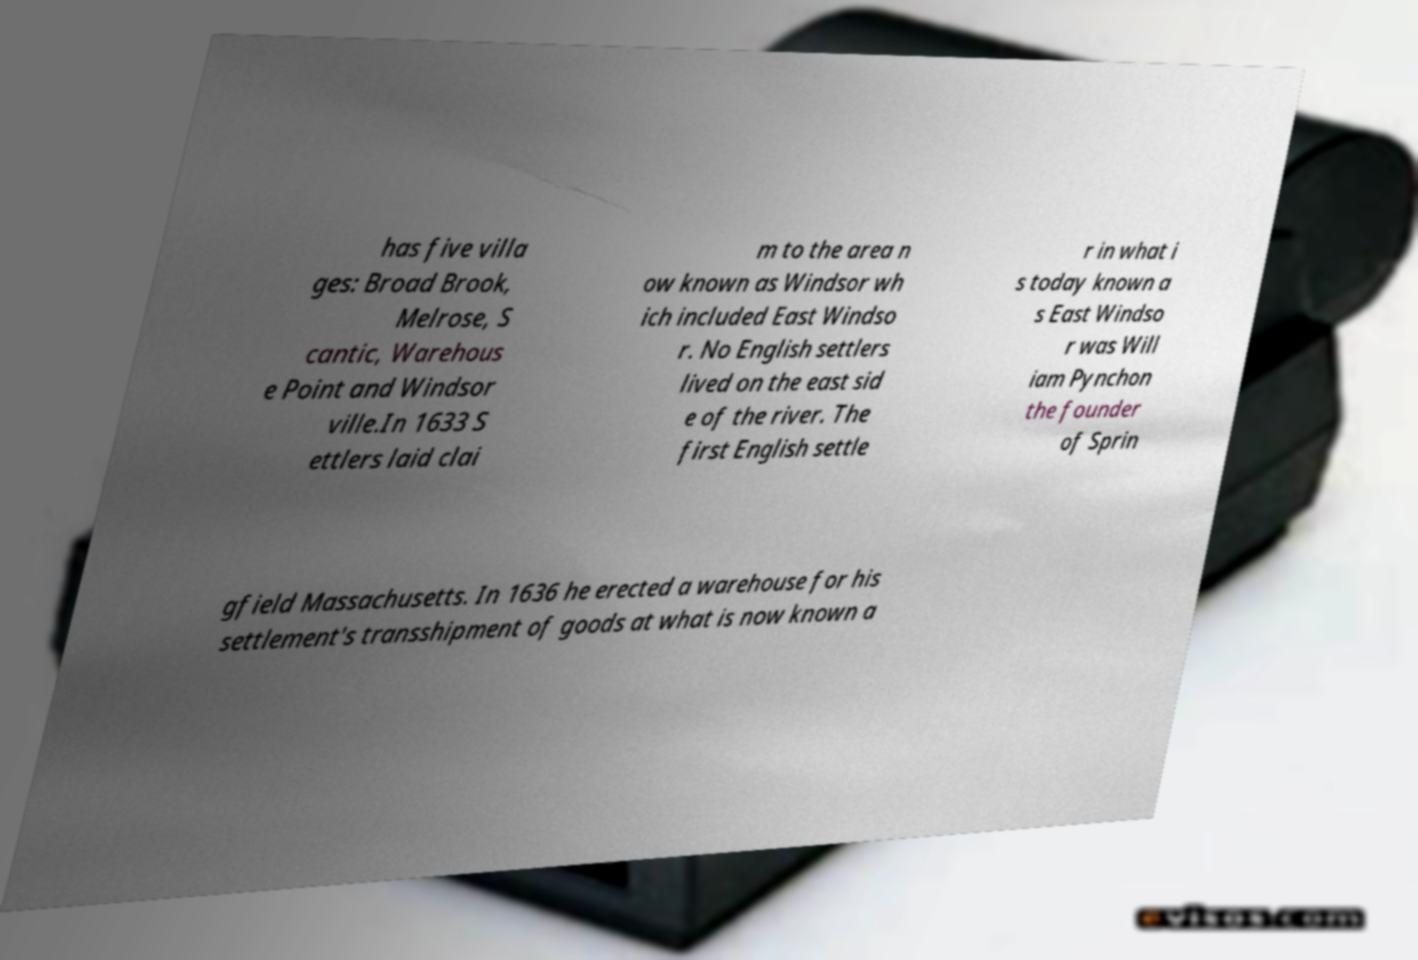What messages or text are displayed in this image? I need them in a readable, typed format. has five villa ges: Broad Brook, Melrose, S cantic, Warehous e Point and Windsor ville.In 1633 S ettlers laid clai m to the area n ow known as Windsor wh ich included East Windso r. No English settlers lived on the east sid e of the river. The first English settle r in what i s today known a s East Windso r was Will iam Pynchon the founder of Sprin gfield Massachusetts. In 1636 he erected a warehouse for his settlement's transshipment of goods at what is now known a 